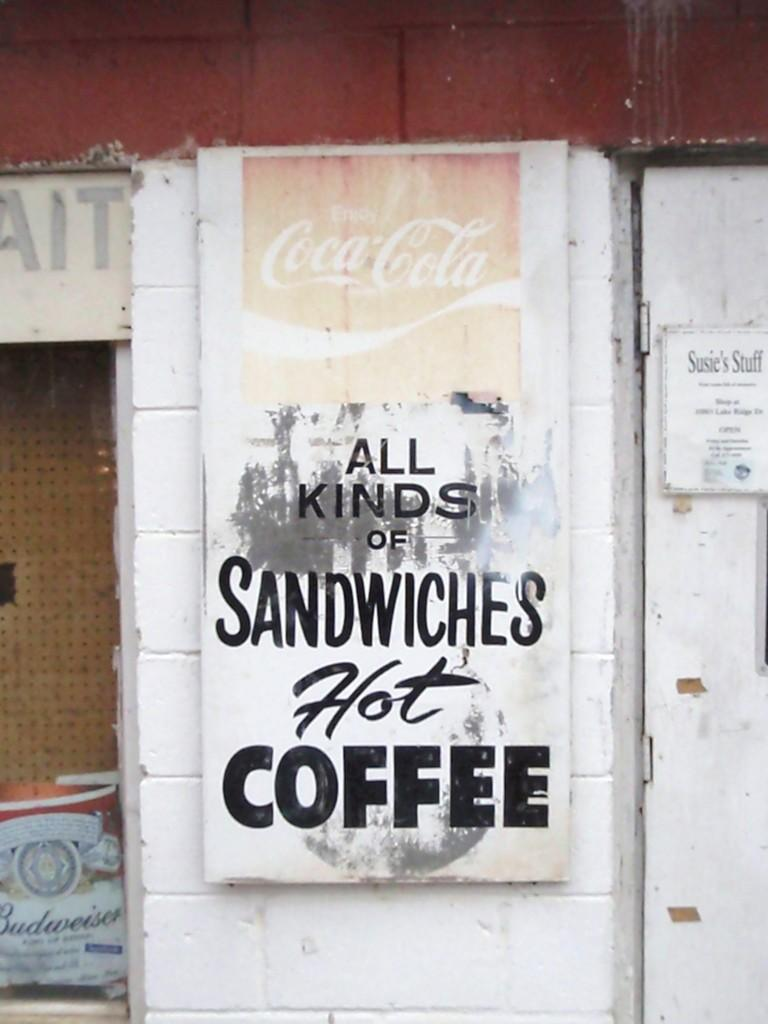What is present on the wall in the image? There is a board pasted on the wall in the image. Can you describe the door in the image? There is a door on the right side of the wall, and there is a paper pasted on it. What is the primary function of the door in the image? The primary function of the door is to provide access to another room or area. How many trees are visible in the image? There are no trees visible in the image. What type of door is present on the left side of the wall? The image does not show a door on the left side of the wall; it only shows a door on the right side. 